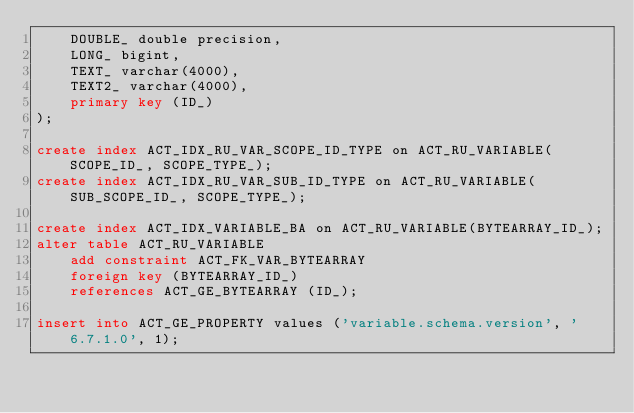<code> <loc_0><loc_0><loc_500><loc_500><_SQL_>    DOUBLE_ double precision,
    LONG_ bigint,
    TEXT_ varchar(4000),
    TEXT2_ varchar(4000),
    primary key (ID_)
);

create index ACT_IDX_RU_VAR_SCOPE_ID_TYPE on ACT_RU_VARIABLE(SCOPE_ID_, SCOPE_TYPE_);
create index ACT_IDX_RU_VAR_SUB_ID_TYPE on ACT_RU_VARIABLE(SUB_SCOPE_ID_, SCOPE_TYPE_);

create index ACT_IDX_VARIABLE_BA on ACT_RU_VARIABLE(BYTEARRAY_ID_);
alter table ACT_RU_VARIABLE 
    add constraint ACT_FK_VAR_BYTEARRAY 
    foreign key (BYTEARRAY_ID_) 
    references ACT_GE_BYTEARRAY (ID_);

insert into ACT_GE_PROPERTY values ('variable.schema.version', '6.7.1.0', 1);
</code> 